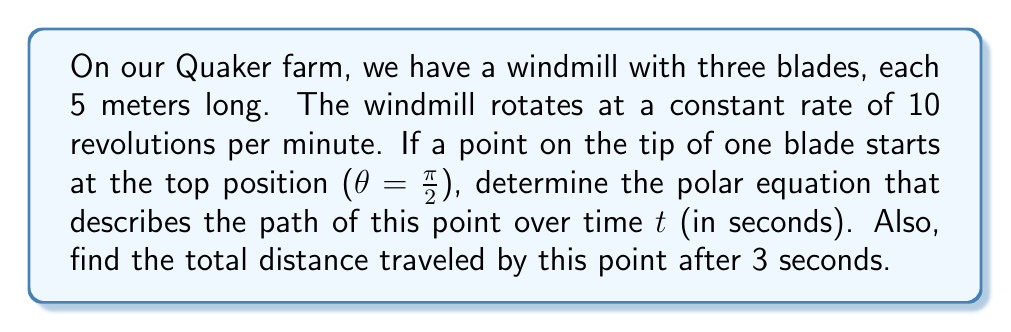Show me your answer to this math problem. Let's approach this step-by-step:

1) First, we need to determine the angular velocity ω in radians per second:
   $$ω = 10 \text{ rev/min} \cdot \frac{2π \text{ rad/rev}}{60 \text{ sec/min}} = \frac{π}{3} \text{ rad/sec}$$

2) The angle θ at time t will be:
   $$θ = \frac{π}{2} - \frac{π}{3}t$$
   We subtract because the windmill rotates clockwise.

3) The radius r is constant at 5 meters.

4) Therefore, the polar equation is:
   $$r = 5, \quad θ = \frac{π}{2} - \frac{π}{3}t$$

5) To find the distance traveled, we need to calculate the arc length:
   $$s = rθ = 5 \cdot \frac{π}{3}t = \frac{5π}{3}t$$

6) After 3 seconds, the distance traveled is:
   $$s = \frac{5π}{3} \cdot 3 = 5π \text{ meters}$$

[asy]
import geometry;

size(200);
draw(Circle((0,0),5), blue);
draw((0,0)--(0,5), red);
draw((0,0)--(5*cos(pi/6),5*sin(pi/6)), red);
draw((0,0)--(5*cos(pi/3),5*sin(pi/3)), red);
label("Start", (0,5.5), N);
label("After 1 sec", (5*cos(pi/6),5*sin(pi/6)), NE);
label("After 2 sec", (5*cos(pi/3),5*sin(pi/3)), SE);
[/asy]
Answer: The polar equation is $r = 5, θ = \frac{π}{2} - \frac{π}{3}t$, and the total distance traveled after 3 seconds is $5π$ meters. 